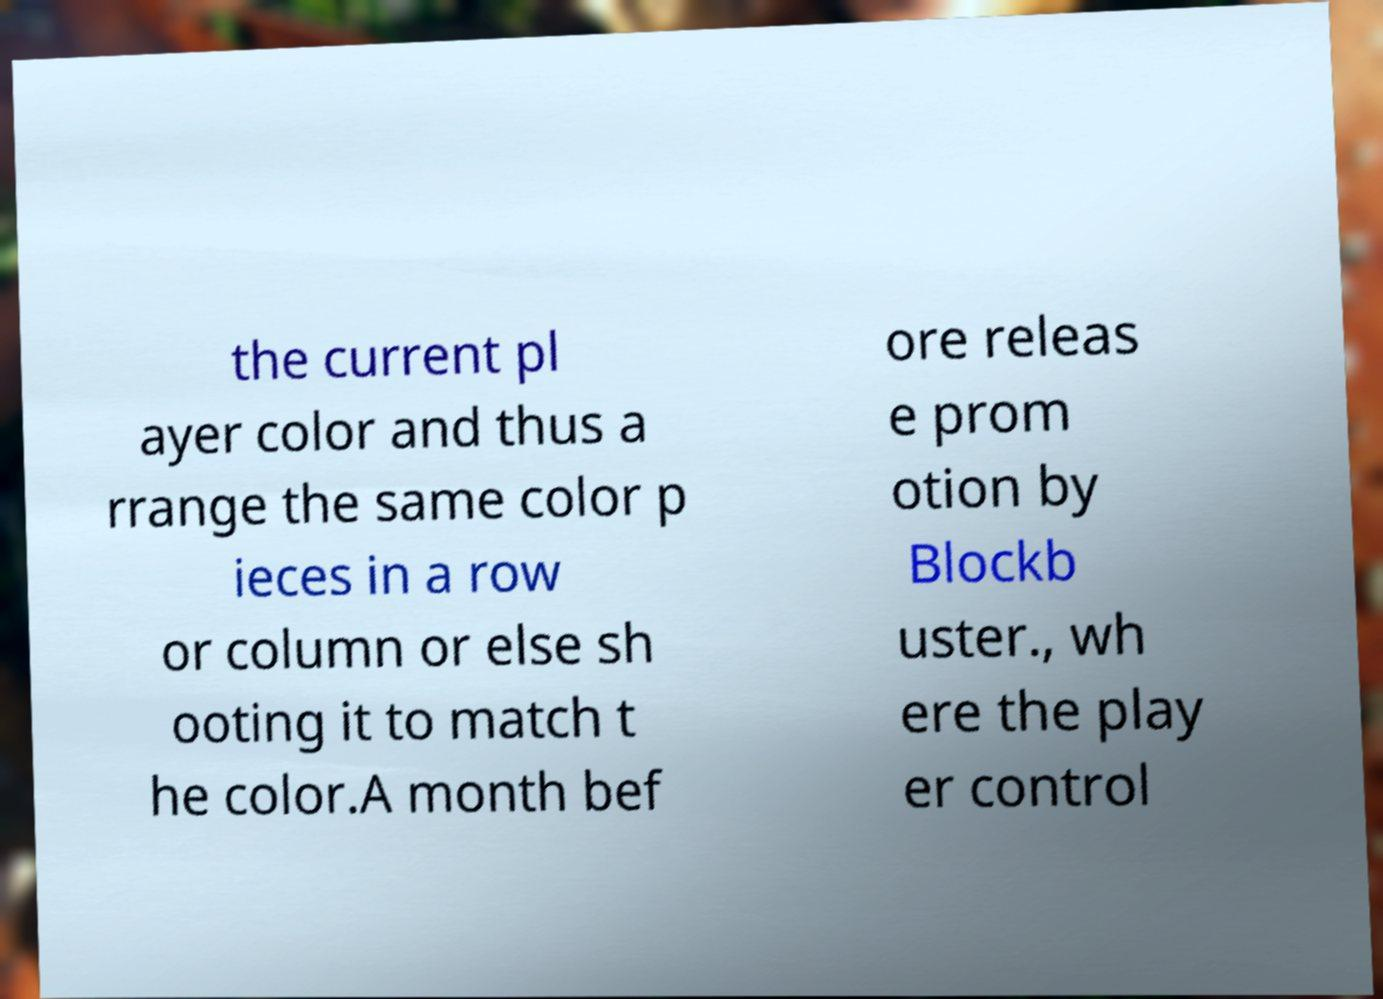For documentation purposes, I need the text within this image transcribed. Could you provide that? the current pl ayer color and thus a rrange the same color p ieces in a row or column or else sh ooting it to match t he color.A month bef ore releas e prom otion by Blockb uster., wh ere the play er control 